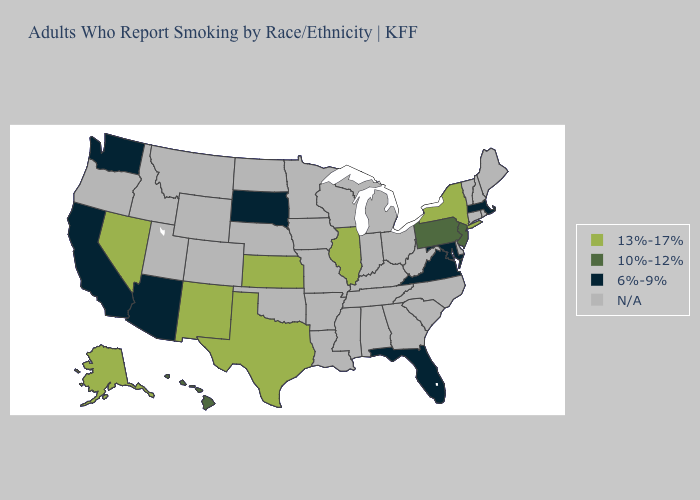Name the states that have a value in the range N/A?
Write a very short answer. Alabama, Arkansas, Colorado, Connecticut, Delaware, Georgia, Idaho, Indiana, Iowa, Kentucky, Louisiana, Maine, Michigan, Minnesota, Mississippi, Missouri, Montana, Nebraska, New Hampshire, North Carolina, North Dakota, Ohio, Oklahoma, Oregon, Rhode Island, South Carolina, Tennessee, Utah, Vermont, West Virginia, Wisconsin, Wyoming. What is the lowest value in the USA?
Be succinct. 6%-9%. Does the first symbol in the legend represent the smallest category?
Write a very short answer. No. Does Nevada have the lowest value in the West?
Concise answer only. No. Does Maryland have the lowest value in the South?
Concise answer only. Yes. What is the lowest value in the USA?
Write a very short answer. 6%-9%. Name the states that have a value in the range N/A?
Answer briefly. Alabama, Arkansas, Colorado, Connecticut, Delaware, Georgia, Idaho, Indiana, Iowa, Kentucky, Louisiana, Maine, Michigan, Minnesota, Mississippi, Missouri, Montana, Nebraska, New Hampshire, North Carolina, North Dakota, Ohio, Oklahoma, Oregon, Rhode Island, South Carolina, Tennessee, Utah, Vermont, West Virginia, Wisconsin, Wyoming. Does the first symbol in the legend represent the smallest category?
Quick response, please. No. Which states have the highest value in the USA?
Concise answer only. Alaska, Illinois, Kansas, Nevada, New Mexico, New York, Texas. Is the legend a continuous bar?
Concise answer only. No. What is the lowest value in the South?
Quick response, please. 6%-9%. What is the lowest value in the USA?
Concise answer only. 6%-9%. Does New Jersey have the lowest value in the Northeast?
Give a very brief answer. No. What is the highest value in the MidWest ?
Concise answer only. 13%-17%. 